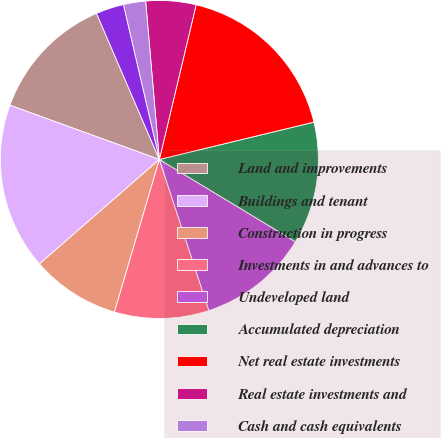Convert chart. <chart><loc_0><loc_0><loc_500><loc_500><pie_chart><fcel>Land and improvements<fcel>Buildings and tenant<fcel>Construction in progress<fcel>Investments in and advances to<fcel>Undeveloped land<fcel>Accumulated depreciation<fcel>Net real estate investments<fcel>Real estate investments and<fcel>Cash and cash equivalents<fcel>Accounts receivable net of<nl><fcel>12.99%<fcel>16.95%<fcel>9.04%<fcel>9.6%<fcel>11.3%<fcel>12.43%<fcel>17.51%<fcel>5.09%<fcel>2.26%<fcel>2.83%<nl></chart> 